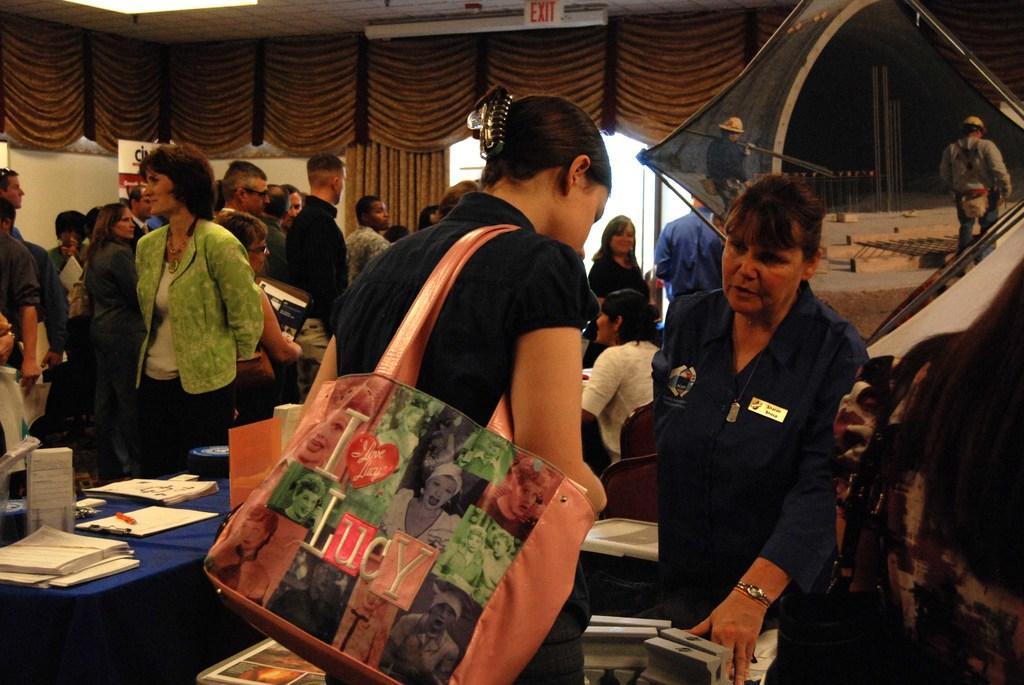Can you describe this image briefly? In this picture I can see group of people standing, there are papers, pen and a wooden pad on the table, there are boards, chairs, and in the background there are some objects. 